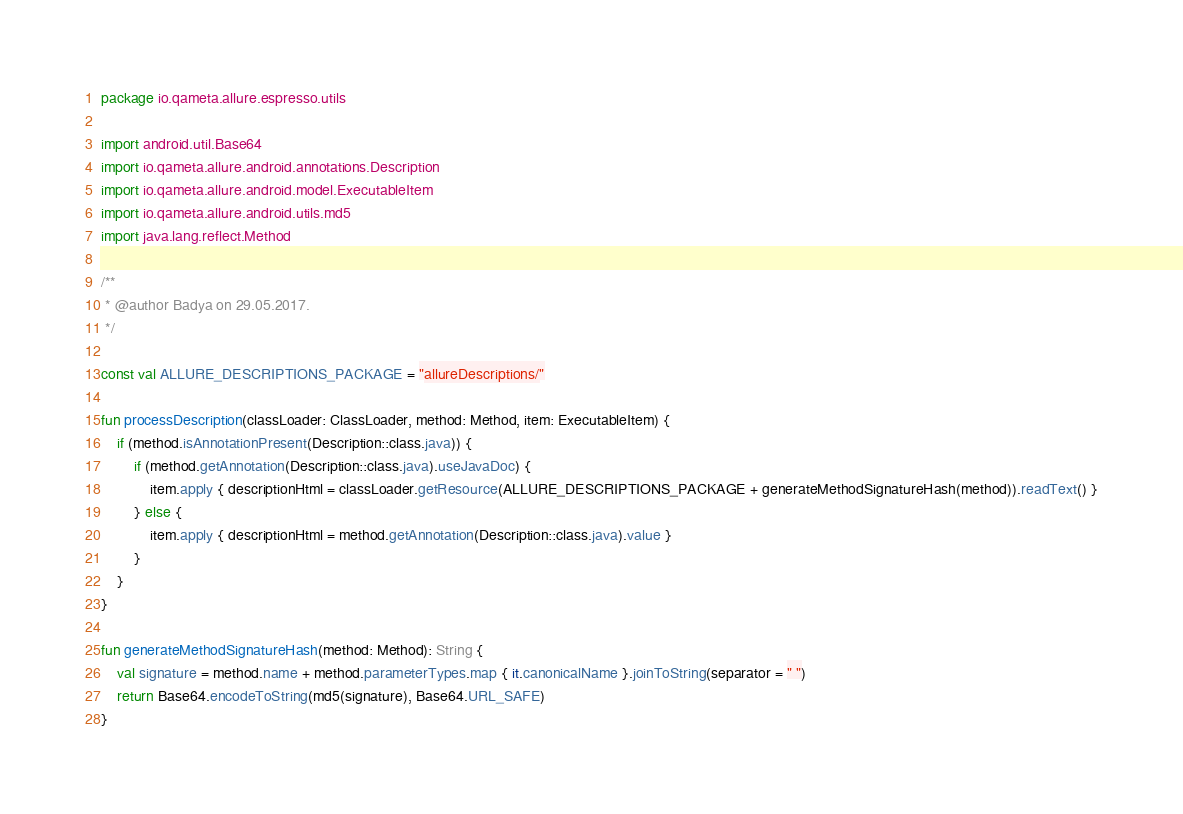<code> <loc_0><loc_0><loc_500><loc_500><_Kotlin_>package io.qameta.allure.espresso.utils

import android.util.Base64
import io.qameta.allure.android.annotations.Description
import io.qameta.allure.android.model.ExecutableItem
import io.qameta.allure.android.utils.md5
import java.lang.reflect.Method

/**
 * @author Badya on 29.05.2017.
 */

const val ALLURE_DESCRIPTIONS_PACKAGE = "allureDescriptions/"

fun processDescription(classLoader: ClassLoader, method: Method, item: ExecutableItem) {
    if (method.isAnnotationPresent(Description::class.java)) {
        if (method.getAnnotation(Description::class.java).useJavaDoc) {
            item.apply { descriptionHtml = classLoader.getResource(ALLURE_DESCRIPTIONS_PACKAGE + generateMethodSignatureHash(method)).readText() }
        } else {
            item.apply { descriptionHtml = method.getAnnotation(Description::class.java).value }
        }
    }
}

fun generateMethodSignatureHash(method: Method): String {
    val signature = method.name + method.parameterTypes.map { it.canonicalName }.joinToString(separator = " ")
    return Base64.encodeToString(md5(signature), Base64.URL_SAFE)
}</code> 